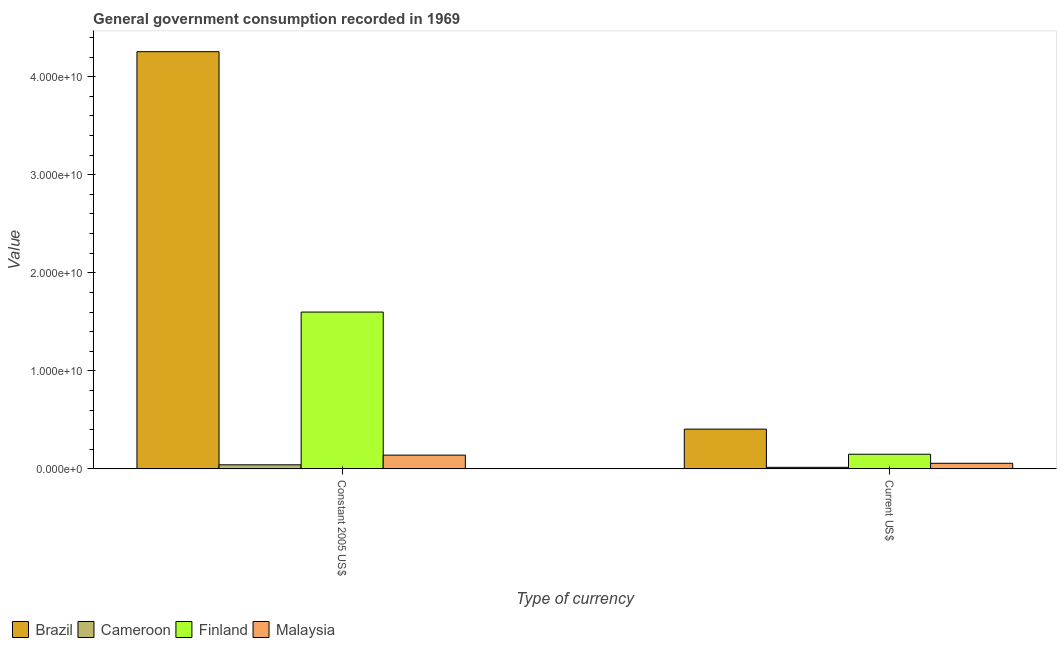Are the number of bars per tick equal to the number of legend labels?
Provide a succinct answer. Yes. Are the number of bars on each tick of the X-axis equal?
Provide a succinct answer. Yes. How many bars are there on the 1st tick from the left?
Offer a very short reply. 4. What is the label of the 1st group of bars from the left?
Provide a succinct answer. Constant 2005 US$. What is the value consumed in current us$ in Brazil?
Your response must be concise. 4.05e+09. Across all countries, what is the maximum value consumed in current us$?
Provide a succinct answer. 4.05e+09. Across all countries, what is the minimum value consumed in current us$?
Your response must be concise. 1.56e+08. In which country was the value consumed in current us$ maximum?
Give a very brief answer. Brazil. In which country was the value consumed in constant 2005 us$ minimum?
Your answer should be compact. Cameroon. What is the total value consumed in current us$ in the graph?
Keep it short and to the point. 6.27e+09. What is the difference between the value consumed in constant 2005 us$ in Malaysia and that in Brazil?
Make the answer very short. -4.12e+1. What is the difference between the value consumed in constant 2005 us$ in Brazil and the value consumed in current us$ in Finland?
Provide a succinct answer. 4.11e+1. What is the average value consumed in current us$ per country?
Give a very brief answer. 1.57e+09. What is the difference between the value consumed in constant 2005 us$ and value consumed in current us$ in Brazil?
Make the answer very short. 3.85e+1. In how many countries, is the value consumed in constant 2005 us$ greater than 8000000000 ?
Provide a succinct answer. 2. What is the ratio of the value consumed in constant 2005 us$ in Finland to that in Cameroon?
Offer a terse response. 38.79. In how many countries, is the value consumed in current us$ greater than the average value consumed in current us$ taken over all countries?
Provide a short and direct response. 1. How many bars are there?
Offer a very short reply. 8. Are all the bars in the graph horizontal?
Offer a very short reply. No. How many countries are there in the graph?
Your answer should be very brief. 4. Does the graph contain any zero values?
Provide a short and direct response. No. Where does the legend appear in the graph?
Offer a terse response. Bottom left. How many legend labels are there?
Keep it short and to the point. 4. How are the legend labels stacked?
Provide a succinct answer. Horizontal. What is the title of the graph?
Give a very brief answer. General government consumption recorded in 1969. Does "Colombia" appear as one of the legend labels in the graph?
Keep it short and to the point. No. What is the label or title of the X-axis?
Offer a very short reply. Type of currency. What is the label or title of the Y-axis?
Make the answer very short. Value. What is the Value of Brazil in Constant 2005 US$?
Offer a very short reply. 4.26e+1. What is the Value in Cameroon in Constant 2005 US$?
Give a very brief answer. 4.12e+08. What is the Value in Finland in Constant 2005 US$?
Your response must be concise. 1.60e+1. What is the Value in Malaysia in Constant 2005 US$?
Provide a succinct answer. 1.40e+09. What is the Value of Brazil in Current US$?
Give a very brief answer. 4.05e+09. What is the Value of Cameroon in Current US$?
Offer a very short reply. 1.56e+08. What is the Value in Finland in Current US$?
Provide a succinct answer. 1.49e+09. What is the Value in Malaysia in Current US$?
Your answer should be compact. 5.67e+08. Across all Type of currency, what is the maximum Value of Brazil?
Keep it short and to the point. 4.26e+1. Across all Type of currency, what is the maximum Value in Cameroon?
Keep it short and to the point. 4.12e+08. Across all Type of currency, what is the maximum Value of Finland?
Keep it short and to the point. 1.60e+1. Across all Type of currency, what is the maximum Value of Malaysia?
Provide a succinct answer. 1.40e+09. Across all Type of currency, what is the minimum Value in Brazil?
Offer a very short reply. 4.05e+09. Across all Type of currency, what is the minimum Value in Cameroon?
Your answer should be compact. 1.56e+08. Across all Type of currency, what is the minimum Value in Finland?
Make the answer very short. 1.49e+09. Across all Type of currency, what is the minimum Value of Malaysia?
Offer a terse response. 5.67e+08. What is the total Value in Brazil in the graph?
Offer a very short reply. 4.66e+1. What is the total Value in Cameroon in the graph?
Provide a succinct answer. 5.69e+08. What is the total Value in Finland in the graph?
Your answer should be very brief. 1.75e+1. What is the total Value of Malaysia in the graph?
Ensure brevity in your answer.  1.97e+09. What is the difference between the Value of Brazil in Constant 2005 US$ and that in Current US$?
Offer a very short reply. 3.85e+1. What is the difference between the Value in Cameroon in Constant 2005 US$ and that in Current US$?
Your answer should be compact. 2.56e+08. What is the difference between the Value of Finland in Constant 2005 US$ and that in Current US$?
Ensure brevity in your answer.  1.45e+1. What is the difference between the Value of Malaysia in Constant 2005 US$ and that in Current US$?
Offer a very short reply. 8.33e+08. What is the difference between the Value in Brazil in Constant 2005 US$ and the Value in Cameroon in Current US$?
Offer a terse response. 4.24e+1. What is the difference between the Value of Brazil in Constant 2005 US$ and the Value of Finland in Current US$?
Ensure brevity in your answer.  4.11e+1. What is the difference between the Value of Brazil in Constant 2005 US$ and the Value of Malaysia in Current US$?
Offer a very short reply. 4.20e+1. What is the difference between the Value of Cameroon in Constant 2005 US$ and the Value of Finland in Current US$?
Keep it short and to the point. -1.08e+09. What is the difference between the Value in Cameroon in Constant 2005 US$ and the Value in Malaysia in Current US$?
Your answer should be very brief. -1.55e+08. What is the difference between the Value in Finland in Constant 2005 US$ and the Value in Malaysia in Current US$?
Your answer should be very brief. 1.54e+1. What is the average Value in Brazil per Type of currency?
Keep it short and to the point. 2.33e+1. What is the average Value of Cameroon per Type of currency?
Give a very brief answer. 2.84e+08. What is the average Value in Finland per Type of currency?
Your answer should be compact. 8.74e+09. What is the average Value of Malaysia per Type of currency?
Your answer should be compact. 9.84e+08. What is the difference between the Value in Brazil and Value in Cameroon in Constant 2005 US$?
Offer a terse response. 4.21e+1. What is the difference between the Value of Brazil and Value of Finland in Constant 2005 US$?
Keep it short and to the point. 2.66e+1. What is the difference between the Value of Brazil and Value of Malaysia in Constant 2005 US$?
Offer a terse response. 4.12e+1. What is the difference between the Value of Cameroon and Value of Finland in Constant 2005 US$?
Provide a succinct answer. -1.56e+1. What is the difference between the Value in Cameroon and Value in Malaysia in Constant 2005 US$?
Offer a very short reply. -9.88e+08. What is the difference between the Value in Finland and Value in Malaysia in Constant 2005 US$?
Give a very brief answer. 1.46e+1. What is the difference between the Value in Brazil and Value in Cameroon in Current US$?
Keep it short and to the point. 3.89e+09. What is the difference between the Value of Brazil and Value of Finland in Current US$?
Provide a short and direct response. 2.56e+09. What is the difference between the Value in Brazil and Value in Malaysia in Current US$?
Provide a short and direct response. 3.48e+09. What is the difference between the Value of Cameroon and Value of Finland in Current US$?
Make the answer very short. -1.33e+09. What is the difference between the Value in Cameroon and Value in Malaysia in Current US$?
Make the answer very short. -4.11e+08. What is the difference between the Value of Finland and Value of Malaysia in Current US$?
Give a very brief answer. 9.24e+08. What is the ratio of the Value of Brazil in Constant 2005 US$ to that in Current US$?
Your answer should be very brief. 10.51. What is the ratio of the Value in Cameroon in Constant 2005 US$ to that in Current US$?
Make the answer very short. 2.64. What is the ratio of the Value of Finland in Constant 2005 US$ to that in Current US$?
Provide a short and direct response. 10.73. What is the ratio of the Value in Malaysia in Constant 2005 US$ to that in Current US$?
Provide a succinct answer. 2.47. What is the difference between the highest and the second highest Value in Brazil?
Your answer should be very brief. 3.85e+1. What is the difference between the highest and the second highest Value of Cameroon?
Give a very brief answer. 2.56e+08. What is the difference between the highest and the second highest Value of Finland?
Make the answer very short. 1.45e+1. What is the difference between the highest and the second highest Value of Malaysia?
Make the answer very short. 8.33e+08. What is the difference between the highest and the lowest Value of Brazil?
Ensure brevity in your answer.  3.85e+1. What is the difference between the highest and the lowest Value in Cameroon?
Your answer should be very brief. 2.56e+08. What is the difference between the highest and the lowest Value of Finland?
Keep it short and to the point. 1.45e+1. What is the difference between the highest and the lowest Value in Malaysia?
Keep it short and to the point. 8.33e+08. 